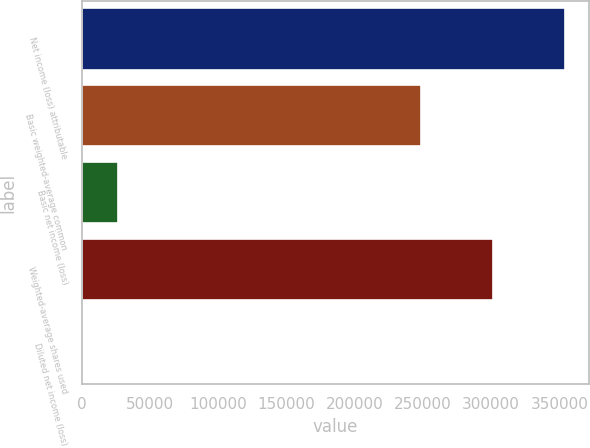Convert chart to OTSL. <chart><loc_0><loc_0><loc_500><loc_500><bar_chart><fcel>Net income (loss) attributable<fcel>Basic weighted-average common<fcel>Basic net income (loss)<fcel>Weighted-average shares used<fcel>Diluted net income (loss)<nl><fcel>354251<fcel>248858<fcel>26349.3<fcel>301555<fcel>1.04<nl></chart> 